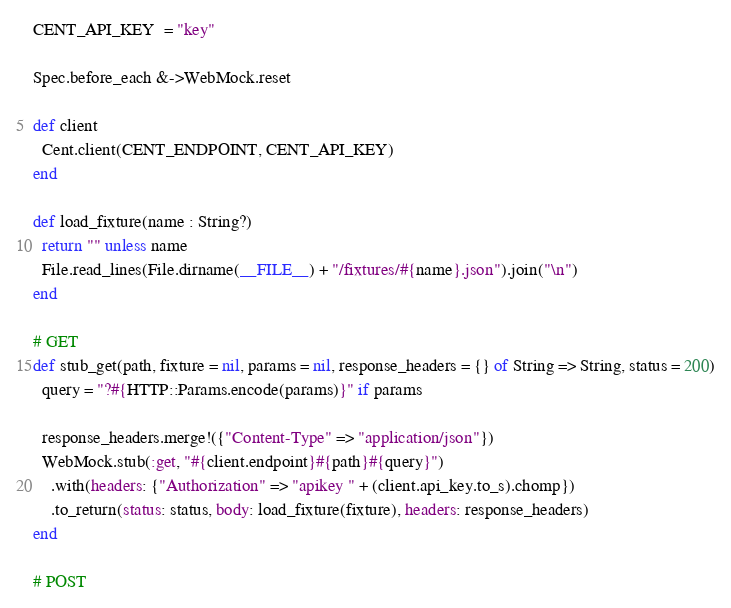Convert code to text. <code><loc_0><loc_0><loc_500><loc_500><_Crystal_>CENT_API_KEY  = "key"

Spec.before_each &->WebMock.reset

def client
  Cent.client(CENT_ENDPOINT, CENT_API_KEY)
end

def load_fixture(name : String?)
  return "" unless name
  File.read_lines(File.dirname(__FILE__) + "/fixtures/#{name}.json").join("\n")
end

# GET
def stub_get(path, fixture = nil, params = nil, response_headers = {} of String => String, status = 200)
  query = "?#{HTTP::Params.encode(params)}" if params

  response_headers.merge!({"Content-Type" => "application/json"})
  WebMock.stub(:get, "#{client.endpoint}#{path}#{query}")
    .with(headers: {"Authorization" => "apikey " + (client.api_key.to_s).chomp})
    .to_return(status: status, body: load_fixture(fixture), headers: response_headers)
end

# POST</code> 